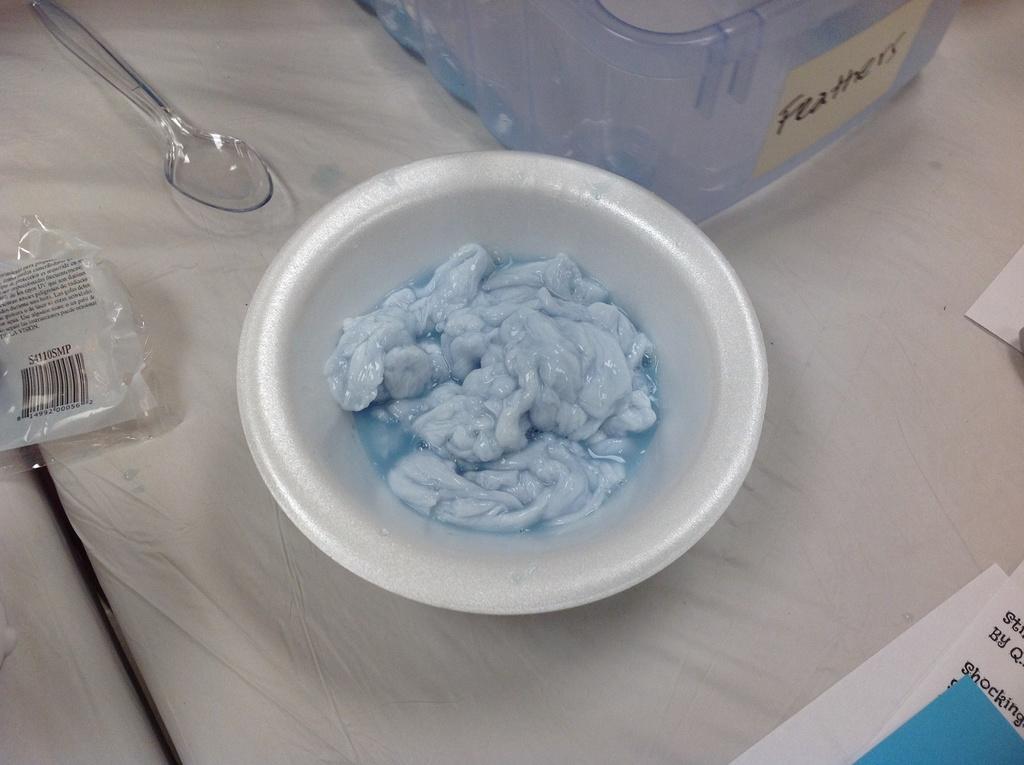Please provide a concise description of this image. In this image I see something in a bowl and I see a spoon, a container, cover and few papers over here. 